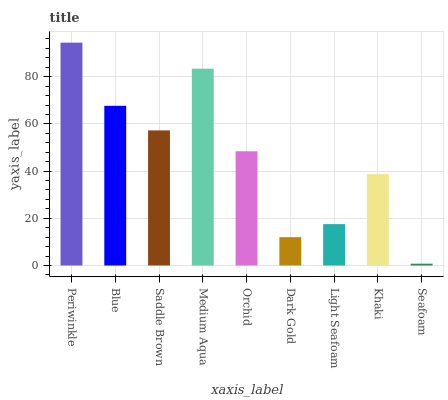Is Seafoam the minimum?
Answer yes or no. Yes. Is Periwinkle the maximum?
Answer yes or no. Yes. Is Blue the minimum?
Answer yes or no. No. Is Blue the maximum?
Answer yes or no. No. Is Periwinkle greater than Blue?
Answer yes or no. Yes. Is Blue less than Periwinkle?
Answer yes or no. Yes. Is Blue greater than Periwinkle?
Answer yes or no. No. Is Periwinkle less than Blue?
Answer yes or no. No. Is Orchid the high median?
Answer yes or no. Yes. Is Orchid the low median?
Answer yes or no. Yes. Is Medium Aqua the high median?
Answer yes or no. No. Is Periwinkle the low median?
Answer yes or no. No. 